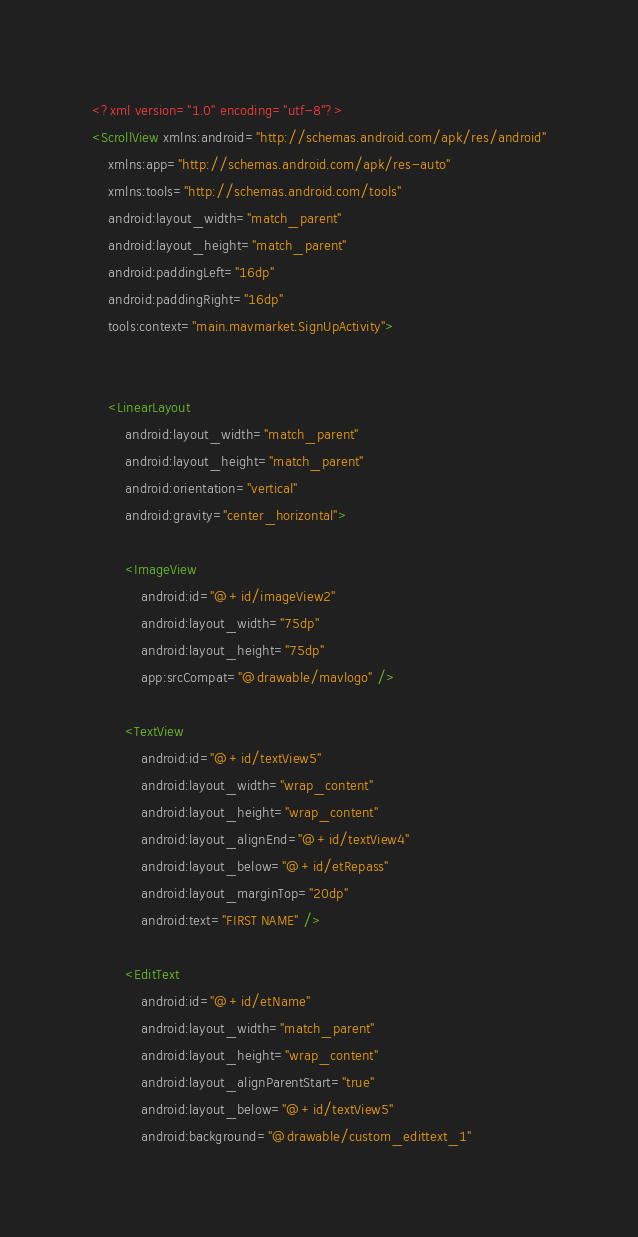Convert code to text. <code><loc_0><loc_0><loc_500><loc_500><_XML_><?xml version="1.0" encoding="utf-8"?>
<ScrollView xmlns:android="http://schemas.android.com/apk/res/android"
    xmlns:app="http://schemas.android.com/apk/res-auto"
    xmlns:tools="http://schemas.android.com/tools"
    android:layout_width="match_parent"
    android:layout_height="match_parent"
    android:paddingLeft="16dp"
    android:paddingRight="16dp"
    tools:context="main.mavmarket.SignUpActivity">


    <LinearLayout
        android:layout_width="match_parent"
        android:layout_height="match_parent"
        android:orientation="vertical"
        android:gravity="center_horizontal">

        <ImageView
            android:id="@+id/imageView2"
            android:layout_width="75dp"
            android:layout_height="75dp"
            app:srcCompat="@drawable/mavlogo" />

        <TextView
            android:id="@+id/textView5"
            android:layout_width="wrap_content"
            android:layout_height="wrap_content"
            android:layout_alignEnd="@+id/textView4"
            android:layout_below="@+id/etRepass"
            android:layout_marginTop="20dp"
            android:text="FIRST NAME" />

        <EditText
            android:id="@+id/etName"
            android:layout_width="match_parent"
            android:layout_height="wrap_content"
            android:layout_alignParentStart="true"
            android:layout_below="@+id/textView5"
            android:background="@drawable/custom_edittext_1"</code> 